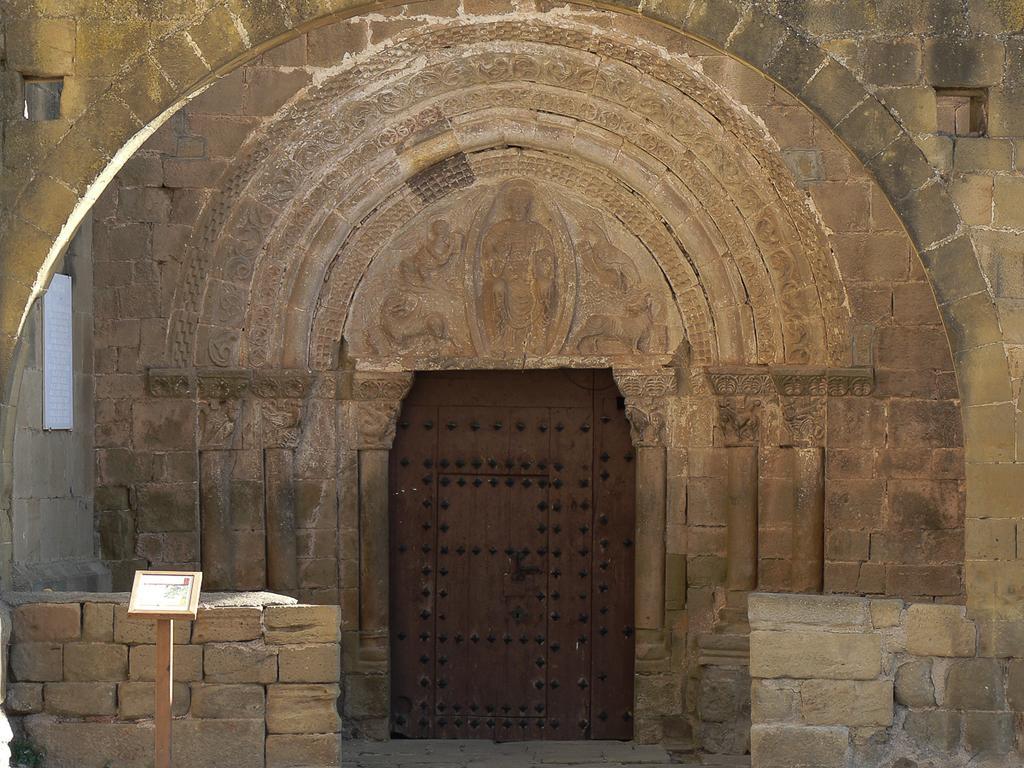Please provide a concise description of this image. This picture seems to be clicked inside. On the left there is a board attached to the wooden stand. In the center there is a building and we can see the stone walls of the building. On the left corner there is a white color board hanging on the wall of a building and we can see a brown color door and the arch and we can see the wall carvings of a person and some animals on the building. 